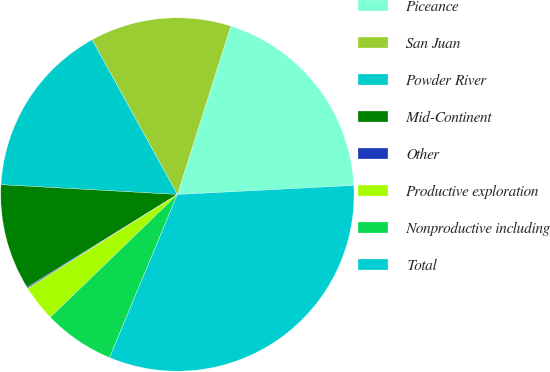Convert chart to OTSL. <chart><loc_0><loc_0><loc_500><loc_500><pie_chart><fcel>Piceance<fcel>San Juan<fcel>Powder River<fcel>Mid-Continent<fcel>Other<fcel>Productive exploration<fcel>Nonproductive including<fcel>Total<nl><fcel>19.3%<fcel>12.9%<fcel>16.1%<fcel>9.7%<fcel>0.11%<fcel>3.3%<fcel>6.5%<fcel>32.09%<nl></chart> 